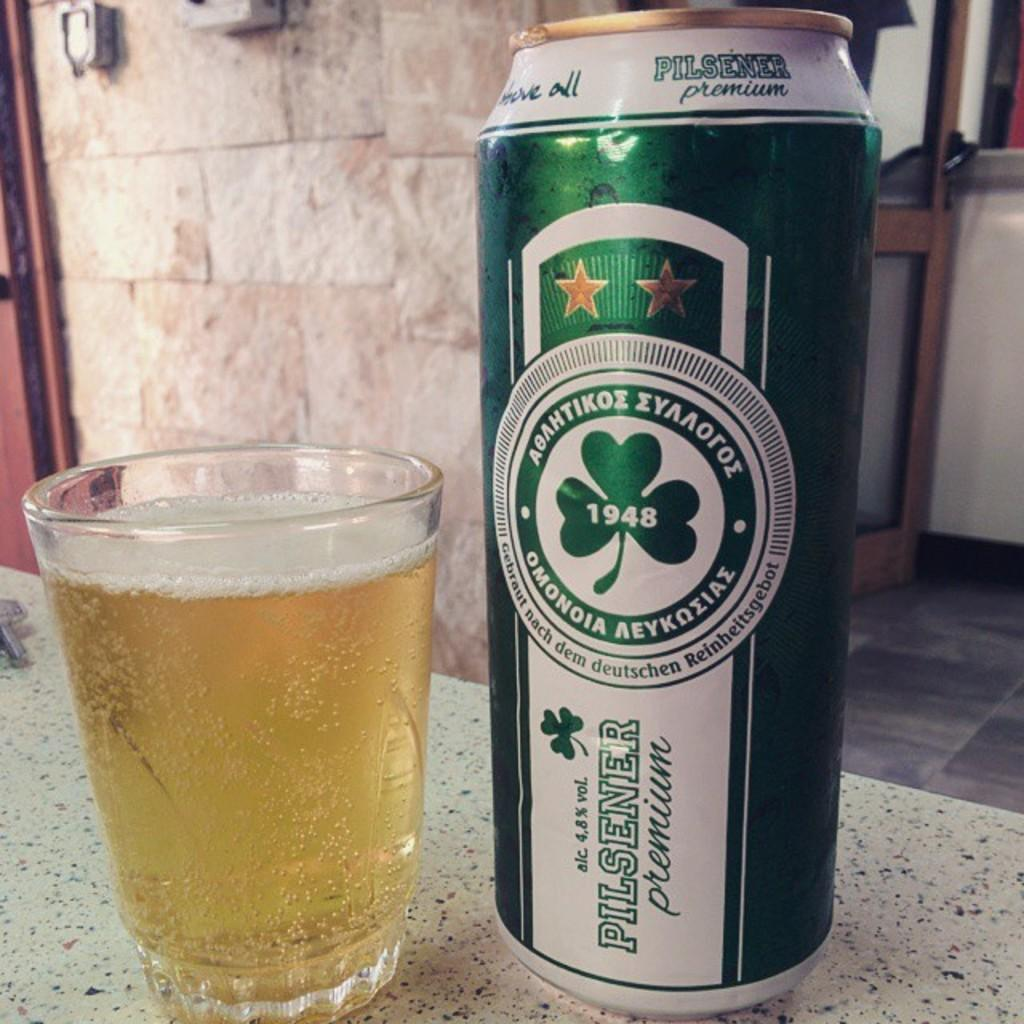<image>
Create a compact narrative representing the image presented. A green can of pilsener premium beer by a glass. 